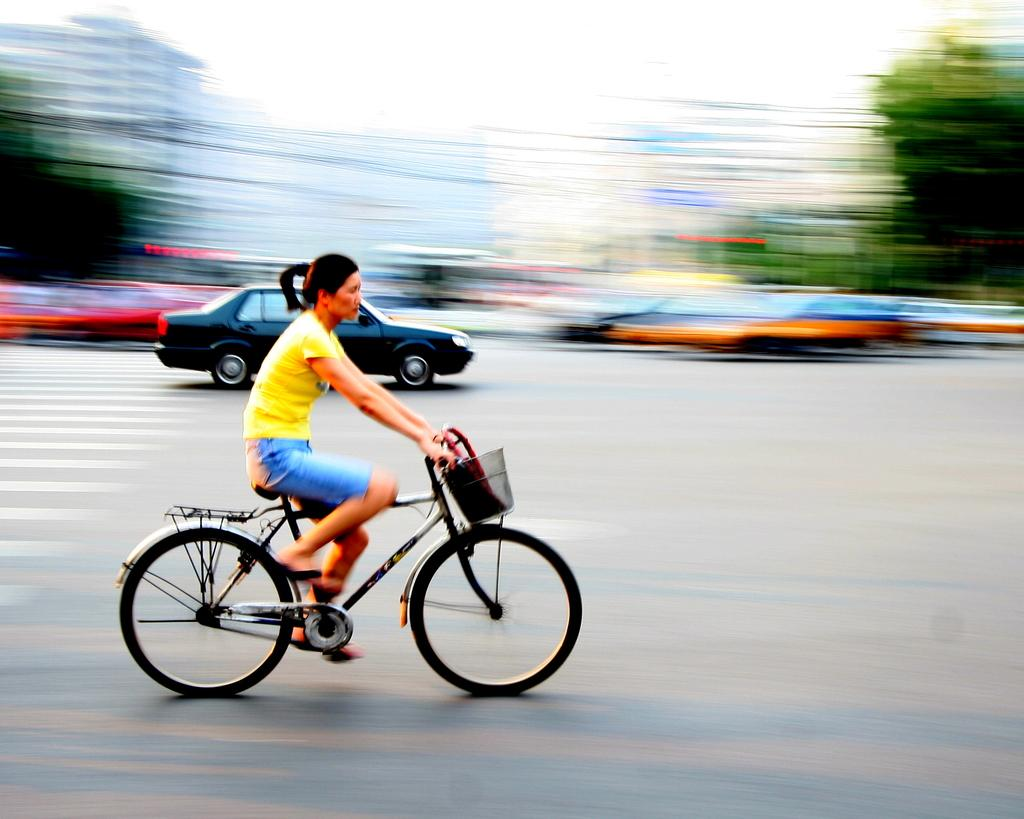What can be observed about the background of the image? The background of the picture is blurry. What is present on the road in the image? There are vehicles on the road. What activity is the woman in the image engaged in? The woman is riding a bicycle. What colors can be seen in the woman's outfit? The woman is wearing a yellow color t-shirt and a blue color short. What type of tools does the carpenter use in the image? There is no carpenter present in the image, so no tools can be observed. How does the woman contribute to reducing pollution in the image? The image does not provide information about the woman's contribution to reducing pollution. 